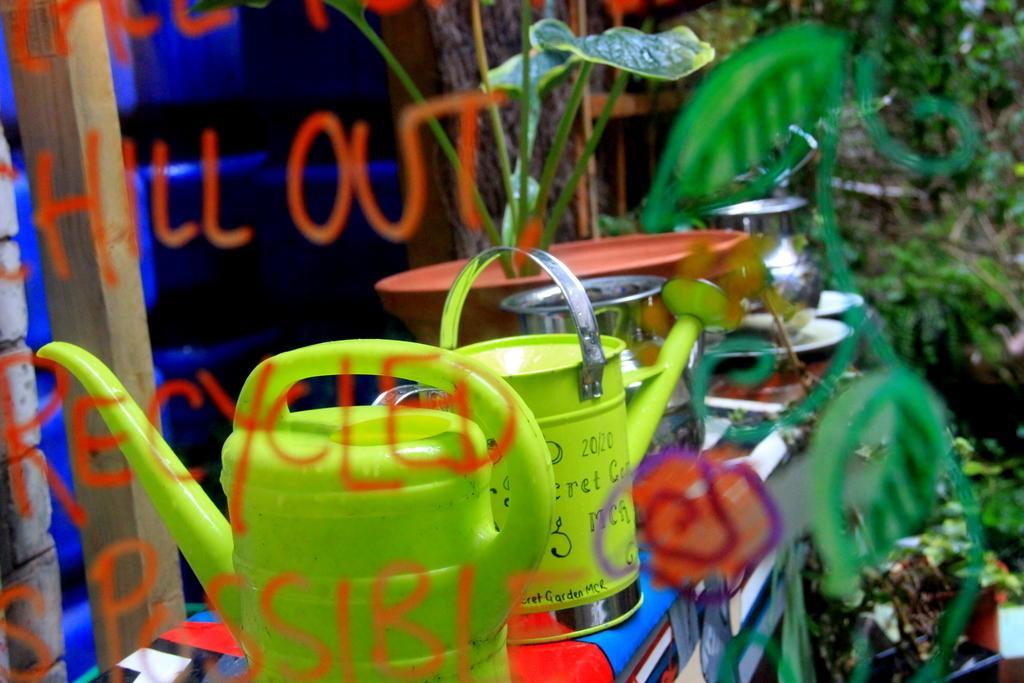Can you describe this image briefly? There is a glass wall with something written on that. In the back there are watering cans, steel pot on a surface. Also there is a pot with a plant. And it is blurred in the background. On the left side there is a wooden pole. 